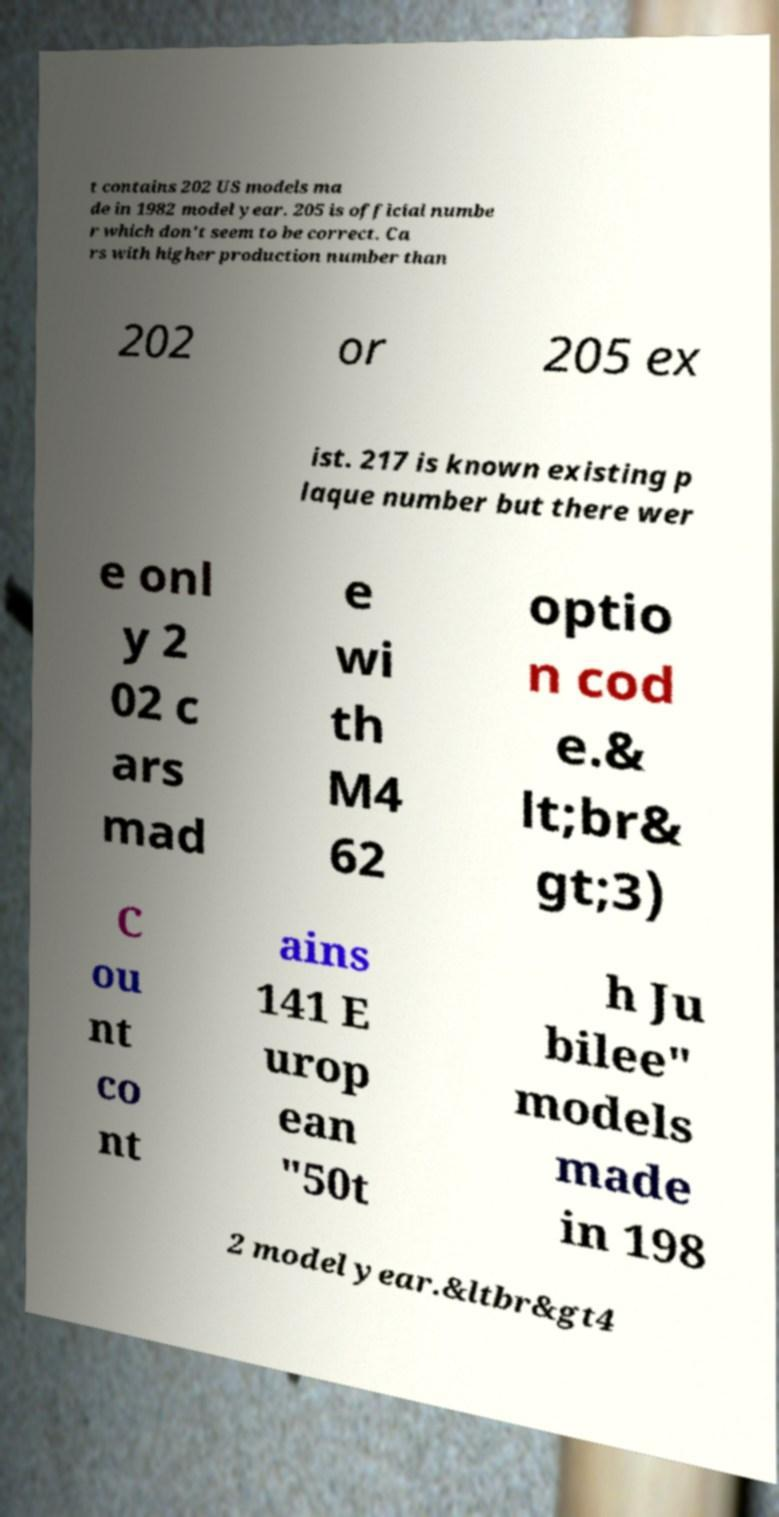Could you extract and type out the text from this image? t contains 202 US models ma de in 1982 model year. 205 is official numbe r which don't seem to be correct. Ca rs with higher production number than 202 or 205 ex ist. 217 is known existing p laque number but there wer e onl y 2 02 c ars mad e wi th M4 62 optio n cod e.& lt;br& gt;3) C ou nt co nt ains 141 E urop ean "50t h Ju bilee" models made in 198 2 model year.&ltbr&gt4 